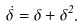Convert formula to latex. <formula><loc_0><loc_0><loc_500><loc_500>\dot { \delta } = \delta + \delta ^ { 2 } .</formula> 